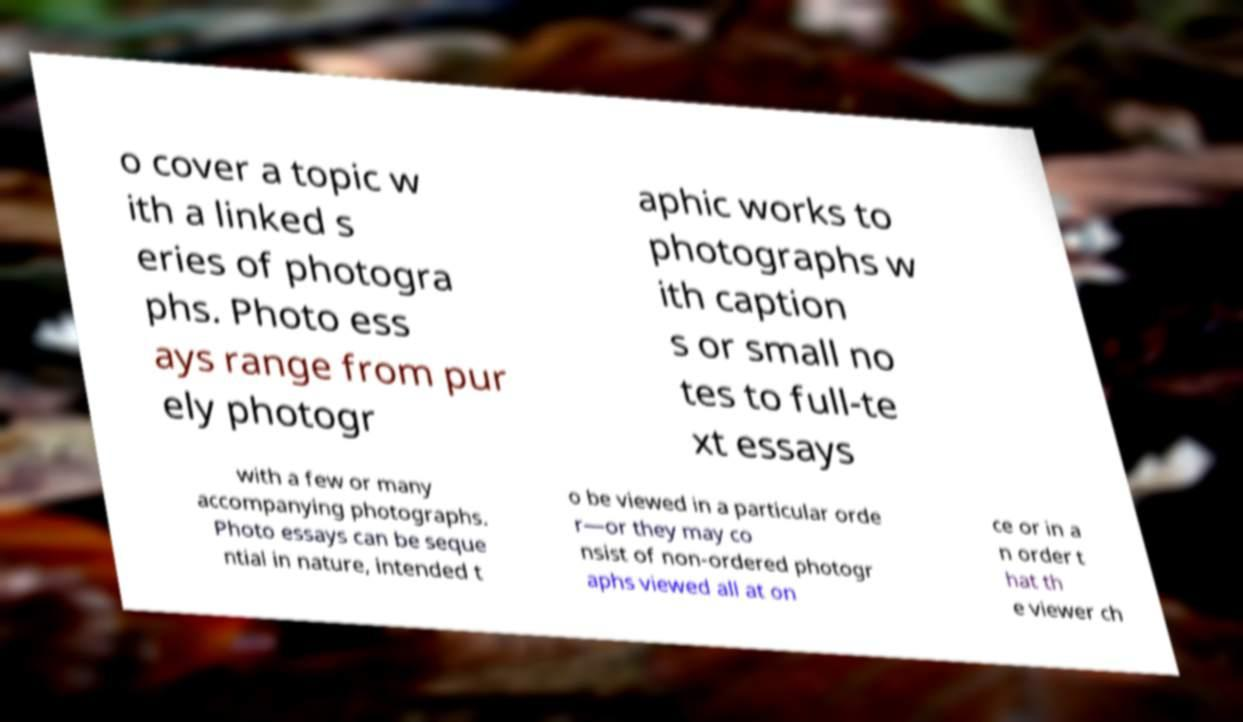Could you assist in decoding the text presented in this image and type it out clearly? o cover a topic w ith a linked s eries of photogra phs. Photo ess ays range from pur ely photogr aphic works to photographs w ith caption s or small no tes to full-te xt essays with a few or many accompanying photographs. Photo essays can be seque ntial in nature, intended t o be viewed in a particular orde r—or they may co nsist of non-ordered photogr aphs viewed all at on ce or in a n order t hat th e viewer ch 